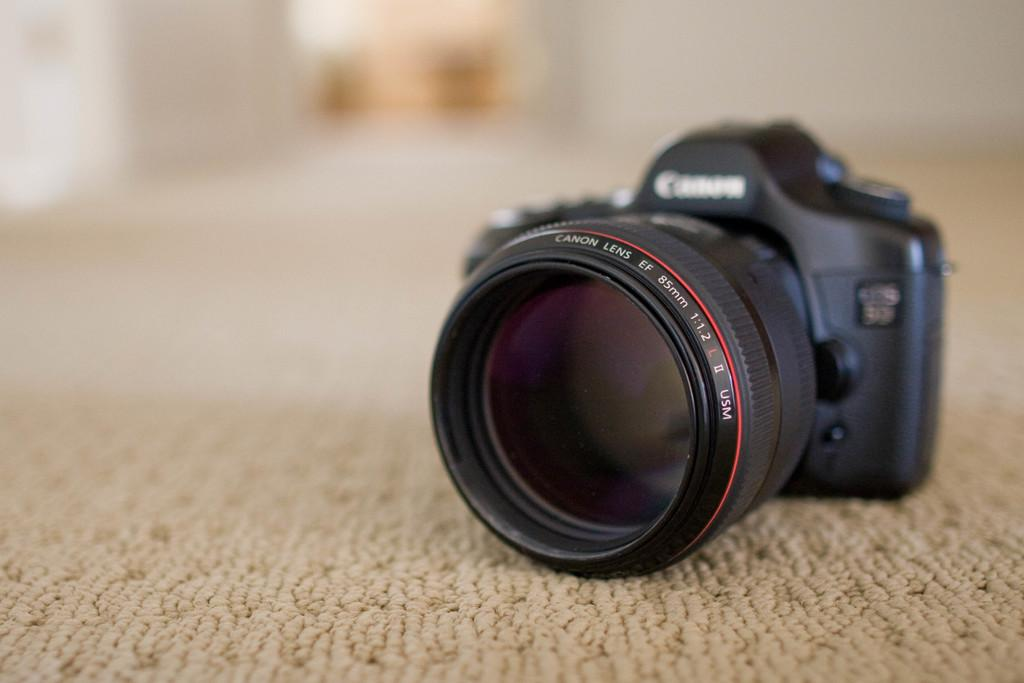What is the main object in the image? There is a camera in the image. Where is the camera placed? The camera is on a mat. Can you describe the background of the image? The background of the image is blurred. What type of mine is visible in the background of the image? There is no mine present in the image; the background is blurred. How does the camera help with arithmetic in the image? The camera does not help with arithmetic in the image; it is a device for capturing images. 